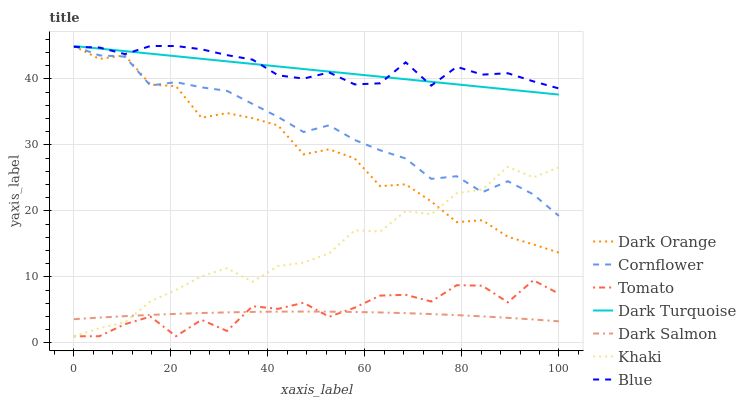Does Dark Orange have the minimum area under the curve?
Answer yes or no. No. Does Dark Orange have the maximum area under the curve?
Answer yes or no. No. Is Dark Orange the smoothest?
Answer yes or no. No. Is Dark Orange the roughest?
Answer yes or no. No. Does Dark Orange have the lowest value?
Answer yes or no. No. Does Khaki have the highest value?
Answer yes or no. No. Is Khaki less than Blue?
Answer yes or no. Yes. Is Dark Orange greater than Dark Salmon?
Answer yes or no. Yes. Does Khaki intersect Blue?
Answer yes or no. No. 